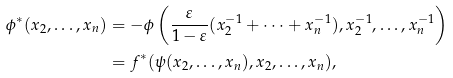Convert formula to latex. <formula><loc_0><loc_0><loc_500><loc_500>\phi ^ { * } ( x _ { 2 } , \dots , x _ { n } ) & = - \phi \left ( \frac { \varepsilon } { 1 - \varepsilon } ( x _ { 2 } ^ { - 1 } + \dots + x _ { n } ^ { - 1 } ) , x _ { 2 } ^ { - 1 } , \dots , x _ { n } ^ { - 1 } \right ) \\ & = f ^ { * } ( \psi ( x _ { 2 } , \dots , x _ { n } ) , x _ { 2 } , \dots , x _ { n } ) ,</formula> 